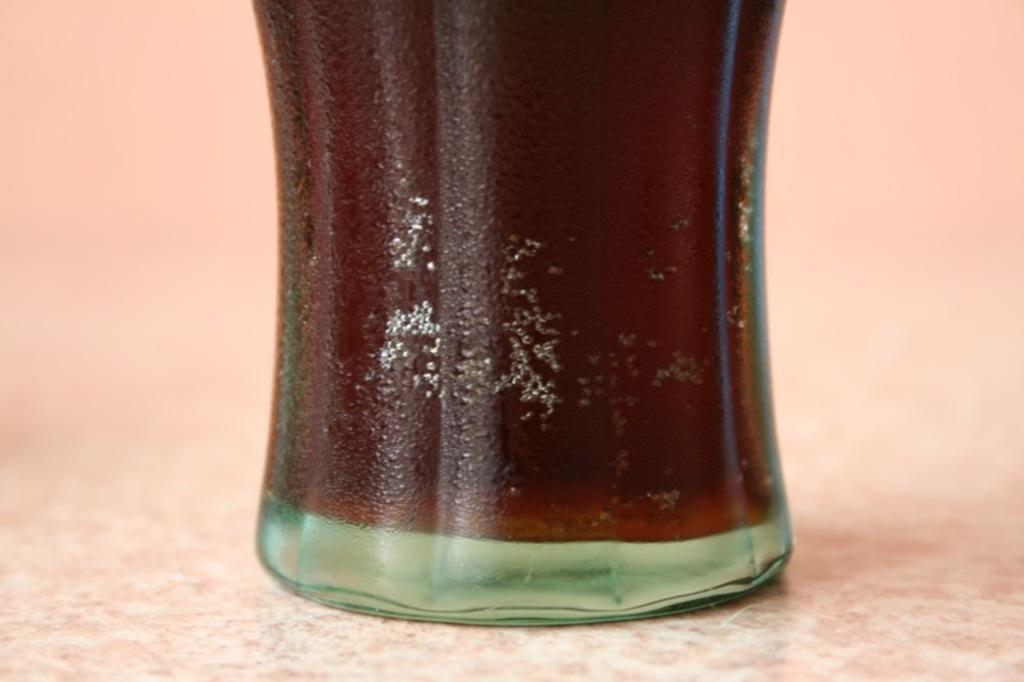What object is placed on a surface in the image? There is a bottle placed on a surface in the image. Can you describe the bottle in the image? The provided facts do not give any details about the appearance or type of bottle. What might the purpose of the bottle be? The bottle's purpose cannot be determined from the provided facts, but it could be used for holding a liquid or other substance. What type of jewel is placed on the surface next to the bottle in the image? There is no mention of a jewel in the provided facts, and therefore no such object can be observed in the image. 